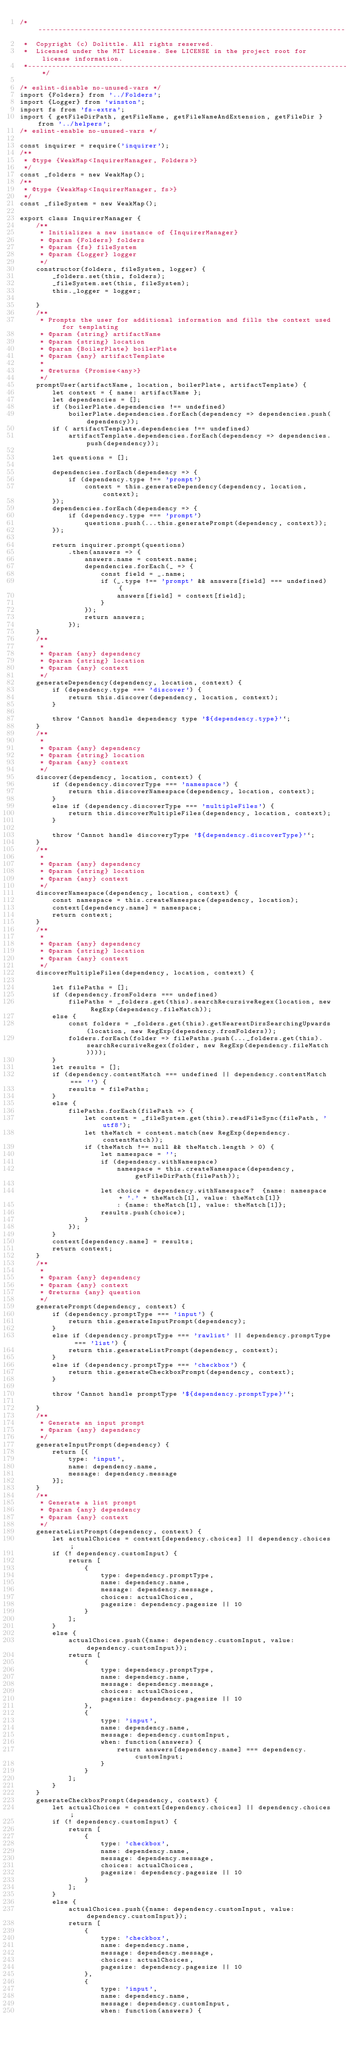<code> <loc_0><loc_0><loc_500><loc_500><_JavaScript_>/*---------------------------------------------------------------------------------------------
 *  Copyright (c) Dolittle. All rights reserved.
 *  Licensed under the MIT License. See LICENSE in the project root for license information.
 *--------------------------------------------------------------------------------------------*/

/* eslint-disable no-unused-vars */
import {Folders} from '../Folders';
import {Logger} from 'winston';
import fs from 'fs-extra';
import { getFileDirPath, getFileName, getFileNameAndExtension, getFileDir } from '../helpers';
/* eslint-enable no-unused-vars */

const inquirer = require('inquirer');
/**
 * @type {WeakMap<InquirerManager, Folders>}
 */
const _folders = new WeakMap();
/**
 * @type {WeakMap<InquirerManager, fs>}
 */
const _fileSystem = new WeakMap();

export class InquirerManager {
    /**
     * Initializes a new instance of {InquirerManager}
     * @param {Folders} folders 
     * @param {fs} fileSystem
     * @param {Logger} logger
     */
    constructor(folders, fileSystem, logger) {
        _folders.set(this, folders);
        _fileSystem.set(this, fileSystem);
        this._logger = logger;
        
    }
    /**
     * Prompts the user for additional information and fills the context used for templating
     * @param {string} artifactName
     * @param {string} location
     * @param {BoilerPlate} boilerPlate 
     * @param {any} artifactTemplate
     * 
     * @returns {Promise<any>}
     */
    promptUser(artifactName, location, boilerPlate, artifactTemplate) {
        let context = { name: artifactName };
        let dependencies = [];
        if (boilerPlate.dependencies !== undefined)
            boilerPlate.dependencies.forEach(dependency => dependencies.push(dependency));
        if ( artifactTemplate.dependencies !== undefined)
            artifactTemplate.dependencies.forEach(dependency => dependencies.push(dependency));
        
        let questions = [];

        dependencies.forEach(dependency => {
            if (dependency.type !== 'prompt')
                context = this.generateDependency(dependency, location, context);
        });
        dependencies.forEach(dependency => {
            if (dependency.type === 'prompt')
                questions.push(...this.generatePrompt(dependency, context));
        });

        return inquirer.prompt(questions)
            .then(answers => {
                answers.name = context.name;
                dependencies.forEach(_ => {
                    const field = _.name;
                    if (_.type !== 'prompt' && answers[field] === undefined) {
                        answers[field] = context[field];
                    }
                });
                return answers;
            });
    }
    /**
     * 
     * @param {any} dependency 
     * @param {string} location
     * @param {any} context 
     */
    generateDependency(dependency, location, context) {
        if (dependency.type === 'discover') {
            return this.discover(dependency, location, context);
        }

        throw `Cannot handle dependency type '${dependency.type}'`;
    }
    /**
     * 
     * @param {any} dependency 
     * @param {string} location 
     * @param {any} context 
     */
    discover(dependency, location, context) {
        if (dependency.discoverType === 'namespace') {
            return this.discoverNamespace(dependency, location, context);
        } 
        else if (dependency.discoverType === 'multipleFiles') {
            return this.discoverMultipleFiles(dependency, location, context);
        }

        throw `Cannot handle discoveryType '${dependency.discoverType}'`;
    }
    /**
     * 
     * @param {any} dependency
     * @param {string} location 
     * @param {any} context 
     */
    discoverNamespace(dependency, location, context) {
        const namespace = this.createNamespace(dependency, location);
        context[dependency.name] = namespace;
        return context;
    }
    /**
     * 
     * @param {any} dependency
     * @param {string} location
     * @param {any} context 
     */
    discoverMultipleFiles(dependency, location, context) {
        
        let filePaths = [];
        if (dependency.fromFolders === undefined)
            filePaths = _folders.get(this).searchRecursiveRegex(location, new RegExp(dependency.fileMatch));
        else {
            const folders = _folders.get(this).getNearestDirsSearchingUpwards(location, new RegExp(dependency.fromFolders));
            folders.forEach(folder => filePaths.push(..._folders.get(this).searchRecursiveRegex(folder, new RegExp(dependency.fileMatch))));
        }
        let results = [];
        if (dependency.contentMatch === undefined || dependency.contentMatch === '') { 
            results = filePaths;
        }
        else {
            filePaths.forEach(filePath => {
                let content = _fileSystem.get(this).readFileSync(filePath, 'utf8');
                let theMatch = content.match(new RegExp(dependency.contentMatch));
                if (theMatch !== null && theMatch.length > 0) {
                    let namespace = '';
                    if (dependency.withNamespace)
                        namespace = this.createNamespace(dependency, getFileDirPath(filePath));

                    let choice = dependency.withNamespace?  {name: namespace + '.' + theMatch[1], value: theMatch[1]}
                        : {name: theMatch[1], value: theMatch[1]};
                    results.push(choice);
                }
            });
        }
        context[dependency.name] = results;
        return context;
    }
    /**
     * 
     * @param {any} dependency
     * @param {any} context
     * @returns {any} question
     */
    generatePrompt(dependency, context) {
        if (dependency.promptType === 'input') {
            return this.generateInputPrompt(dependency);
        }
        else if (dependency.promptType === 'rawlist' || dependency.promptType === 'list') {
            return this.generateListPrompt(dependency, context);
        }
        else if (dependency.promptType === 'checkbox') {
            return this.generateCheckboxPrompt(dependency, context);
        }
        
        throw `Cannot handle promptType '${dependency.promptType}'`;

    }
    /**
     * Generate an input prompt
     * @param {any} dependency
     */
    generateInputPrompt(dependency) {
        return [{
            type: 'input',
            name: dependency.name,
            message: dependency.message
        }];
    }
    /**
     * Generate a list prompt
     * @param {any} dependency
     * @param {any} context 
     */
    generateListPrompt(dependency, context) {
        let actualChoices = context[dependency.choices] || dependency.choices;
        if (! dependency.customInput) {
            return [
                {
                    type: dependency.promptType,
                    name: dependency.name,
                    message: dependency.message,
                    choices: actualChoices,
                    pagesize: dependency.pagesize || 10
                }
            ];
        }
        else {
            actualChoices.push({name: dependency.customInput, value: dependency.customInput});
            return [
                {
                    type: dependency.promptType,
                    name: dependency.name,
                    message: dependency.message,
                    choices: actualChoices,
                    pagesize: dependency.pagesize || 10
                },
                {
                    type: 'input',
                    name: dependency.name,
                    message: dependency.customInput,
                    when: function(answers) {
                        return answers[dependency.name] === dependency.customInput;
                    }
                }
            ];
        }
    }
    generateCheckboxPrompt(dependency, context) {
        let actualChoices = context[dependency.choices] || dependency.choices;
        if (! dependency.customInput) {
            return [
                {
                    type: 'checkbox',
                    name: dependency.name,
                    message: dependency.message,
                    choices: actualChoices,
                    pagesize: dependency.pagesize || 10
                }
            ];
        }
        else {
            actualChoices.push({name: dependency.customInput, value: dependency.customInput});
            return [
                {
                    type: 'checkbox',
                    name: dependency.name,
                    message: dependency.message,
                    choices: actualChoices,
                    pagesize: dependency.pagesize || 10
                },
                {
                    type: 'input',
                    name: dependency.name,
                    message: dependency.customInput,
                    when: function(answers) {</code> 